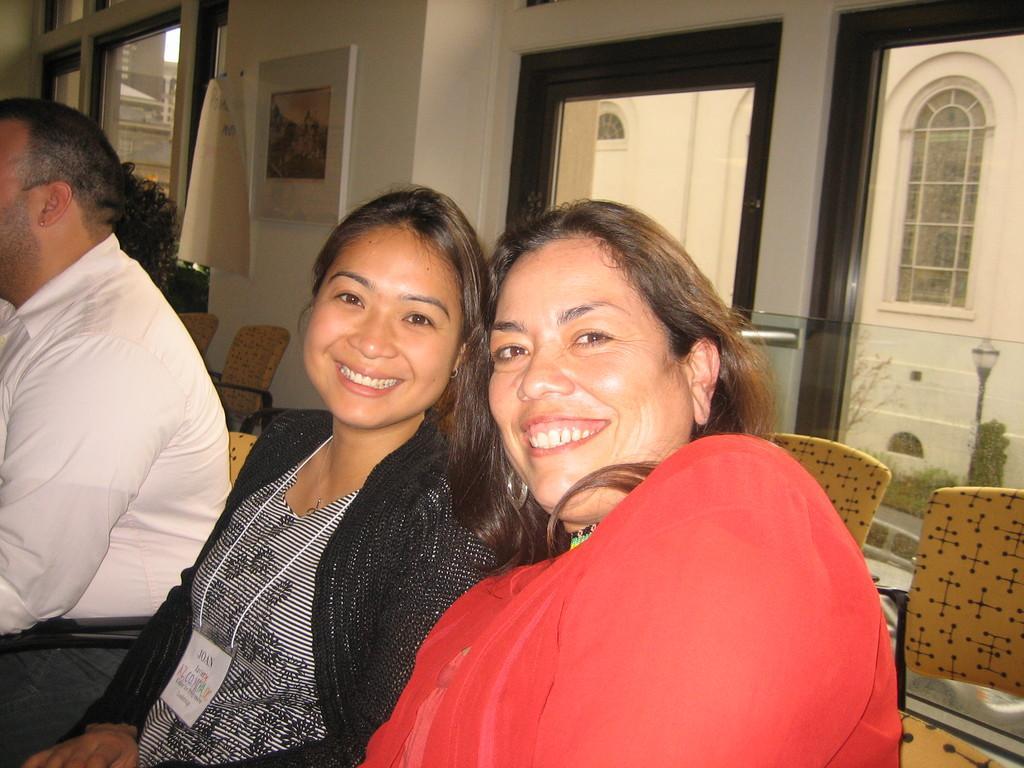Could you give a brief overview of what you see in this image? In this image there are two women and a man sitting on chairs, in the background there are chairs and a wall, for that wall there are glass windows and a frame. 